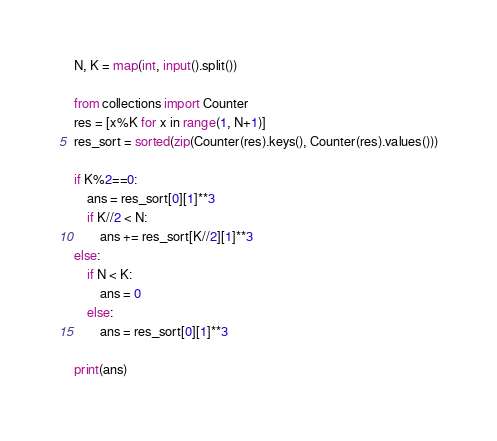Convert code to text. <code><loc_0><loc_0><loc_500><loc_500><_Python_>N, K = map(int, input().split())

from collections import Counter
res = [x%K for x in range(1, N+1)]
res_sort = sorted(zip(Counter(res).keys(), Counter(res).values()))

if K%2==0:
    ans = res_sort[0][1]**3
    if K//2 < N:
        ans += res_sort[K//2][1]**3
else:
    if N < K:
        ans = 0
    else:
        ans = res_sort[0][1]**3

print(ans)</code> 